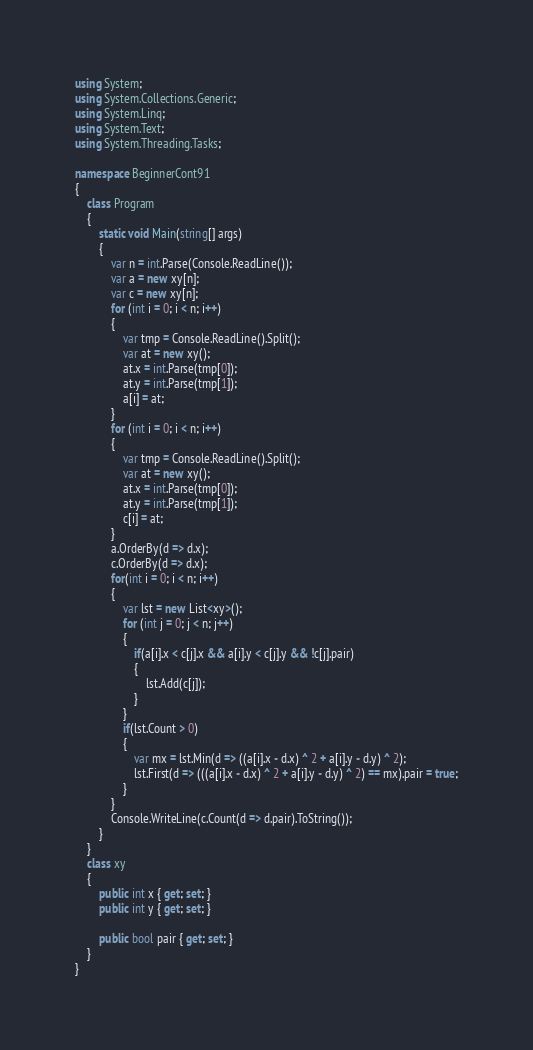<code> <loc_0><loc_0><loc_500><loc_500><_C#_>using System;
using System.Collections.Generic;
using System.Linq;
using System.Text;
using System.Threading.Tasks;

namespace BeginnerCont91
{
    class Program
    {
        static void Main(string[] args)
        {
            var n = int.Parse(Console.ReadLine());
            var a = new xy[n];
            var c = new xy[n];
            for (int i = 0; i < n; i++)
            {
                var tmp = Console.ReadLine().Split();
                var at = new xy();
                at.x = int.Parse(tmp[0]);
                at.y = int.Parse(tmp[1]);
                a[i] = at;
            }
            for (int i = 0; i < n; i++)
            {
                var tmp = Console.ReadLine().Split();
                var at = new xy();
                at.x = int.Parse(tmp[0]);
                at.y = int.Parse(tmp[1]);
                c[i] = at;
            }
            a.OrderBy(d => d.x);
            c.OrderBy(d => d.x);
            for(int i = 0; i < n; i++)
            {
                var lst = new List<xy>();
                for (int j = 0; j < n; j++)
                {
                    if(a[i].x < c[j].x && a[i].y < c[j].y && !c[j].pair)
                    {
                        lst.Add(c[j]);
                    }
                }
                if(lst.Count > 0)
                {
                    var mx = lst.Min(d => ((a[i].x - d.x) ^ 2 + a[i].y - d.y) ^ 2);
                    lst.First(d => (((a[i].x - d.x) ^ 2 + a[i].y - d.y) ^ 2) == mx).pair = true;
                }
            }
            Console.WriteLine(c.Count(d => d.pair).ToString());
        }
    }
    class xy
    {
        public int x { get; set; }
        public int y { get; set; }

        public bool pair { get; set; }
    }
}
</code> 